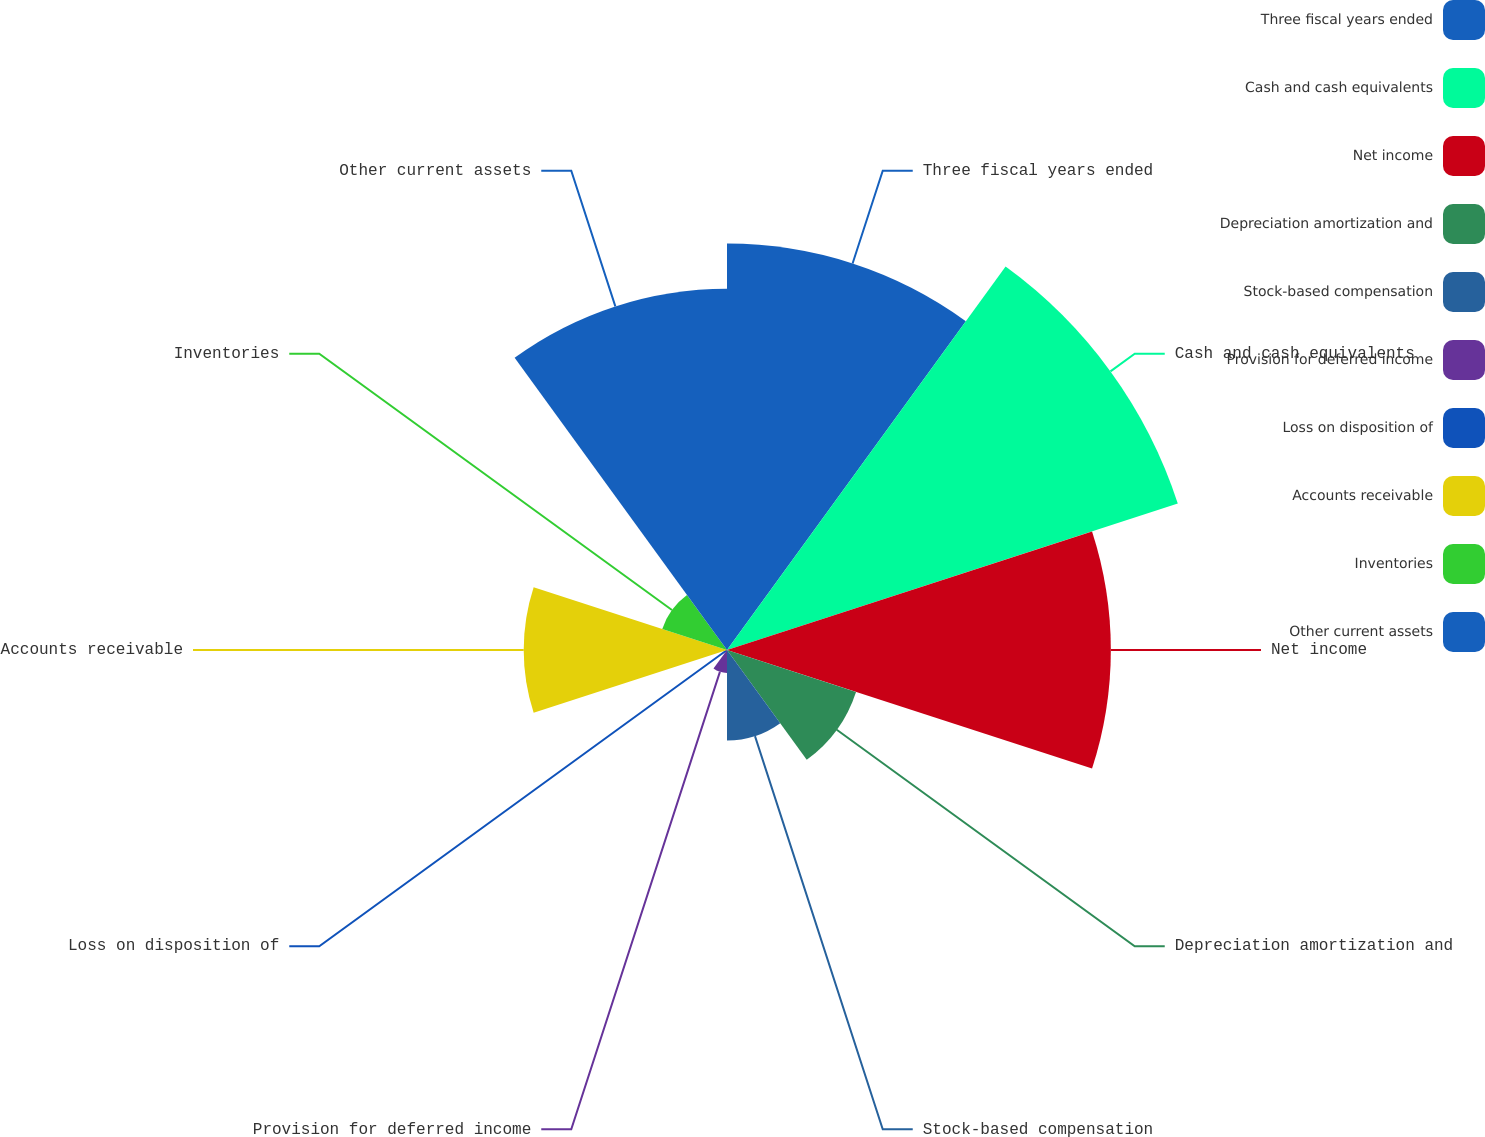<chart> <loc_0><loc_0><loc_500><loc_500><pie_chart><fcel>Three fiscal years ended<fcel>Cash and cash equivalents<fcel>Net income<fcel>Depreciation amortization and<fcel>Stock-based compensation<fcel>Provision for deferred income<fcel>Loss on disposition of<fcel>Accounts receivable<fcel>Inventories<fcel>Other current assets<nl><fcel>18.93%<fcel>22.08%<fcel>17.88%<fcel>6.32%<fcel>4.22%<fcel>1.07%<fcel>0.02%<fcel>9.47%<fcel>3.17%<fcel>16.83%<nl></chart> 